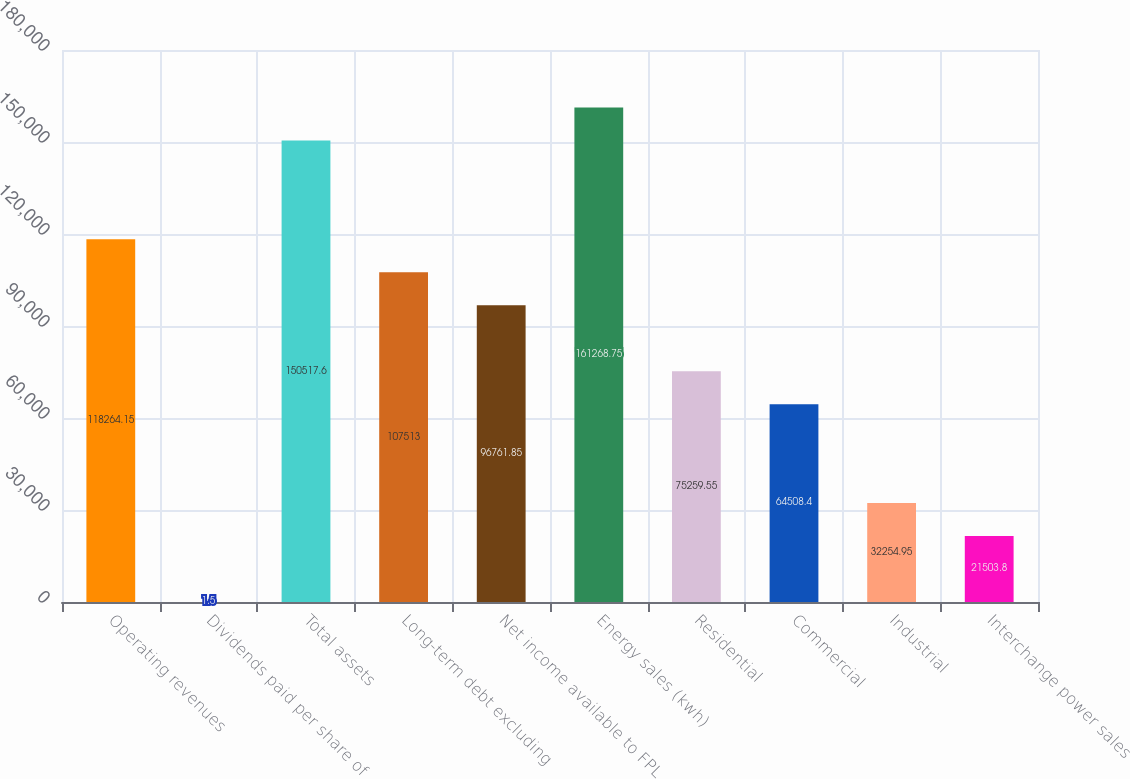<chart> <loc_0><loc_0><loc_500><loc_500><bar_chart><fcel>Operating revenues<fcel>Dividends paid per share of<fcel>Total assets<fcel>Long-term debt excluding<fcel>Net income available to FPL<fcel>Energy sales (kwh)<fcel>Residential<fcel>Commercial<fcel>Industrial<fcel>Interchange power sales<nl><fcel>118264<fcel>1.5<fcel>150518<fcel>107513<fcel>96761.9<fcel>161269<fcel>75259.6<fcel>64508.4<fcel>32255<fcel>21503.8<nl></chart> 